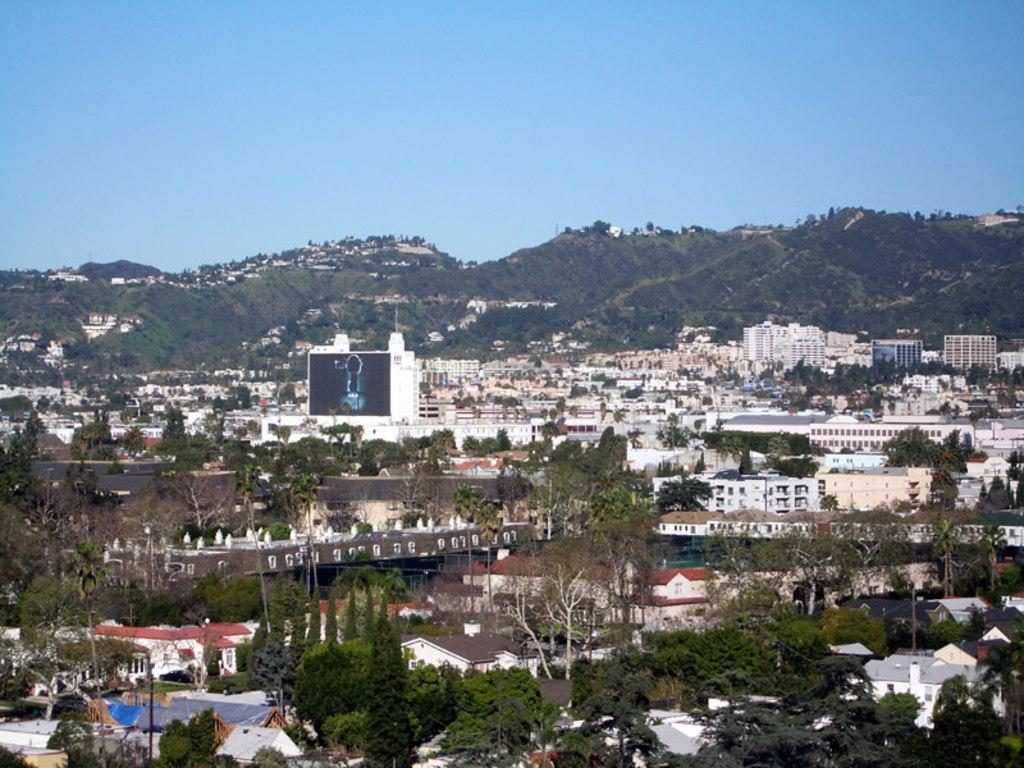What type of structures can be seen in the image? There are houses in the image. What natural elements are present in the image? There are trees, mountains, and plants in the image. What man-made objects can be seen in the image? There are light poles in the image. What is visible in the background of the image? The sky is visible in the background of the image. What time of day is depicted in the image? The time of day cannot be determined from the image, as there are no specific indicators of time. What type of glass object can be seen in the image? There is no glass object present in the image. 